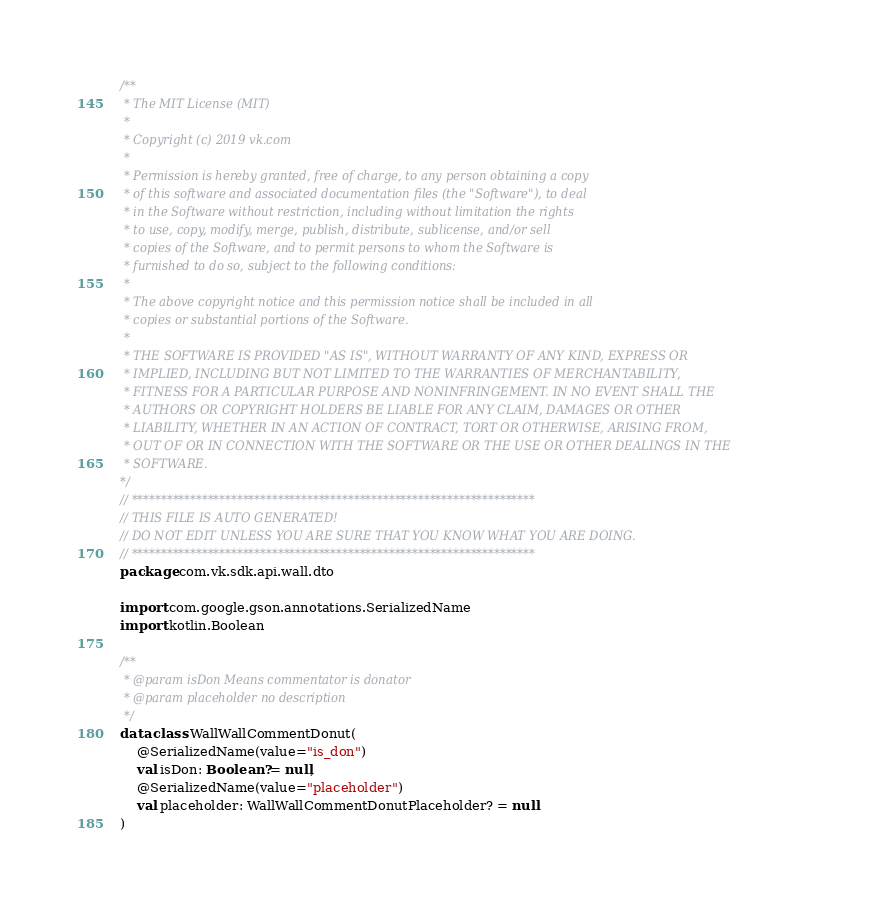Convert code to text. <code><loc_0><loc_0><loc_500><loc_500><_Kotlin_>/**
 * The MIT License (MIT)
 *
 * Copyright (c) 2019 vk.com
 *
 * Permission is hereby granted, free of charge, to any person obtaining a copy
 * of this software and associated documentation files (the "Software"), to deal
 * in the Software without restriction, including without limitation the rights
 * to use, copy, modify, merge, publish, distribute, sublicense, and/or sell
 * copies of the Software, and to permit persons to whom the Software is
 * furnished to do so, subject to the following conditions:
 *
 * The above copyright notice and this permission notice shall be included in all
 * copies or substantial portions of the Software.
 *
 * THE SOFTWARE IS PROVIDED "AS IS", WITHOUT WARRANTY OF ANY KIND, EXPRESS OR
 * IMPLIED, INCLUDING BUT NOT LIMITED TO THE WARRANTIES OF MERCHANTABILITY,
 * FITNESS FOR A PARTICULAR PURPOSE AND NONINFRINGEMENT. IN NO EVENT SHALL THE
 * AUTHORS OR COPYRIGHT HOLDERS BE LIABLE FOR ANY CLAIM, DAMAGES OR OTHER
 * LIABILITY, WHETHER IN AN ACTION OF CONTRACT, TORT OR OTHERWISE, ARISING FROM,
 * OUT OF OR IN CONNECTION WITH THE SOFTWARE OR THE USE OR OTHER DEALINGS IN THE
 * SOFTWARE.
*/
// *********************************************************************
// THIS FILE IS AUTO GENERATED!
// DO NOT EDIT UNLESS YOU ARE SURE THAT YOU KNOW WHAT YOU ARE DOING.
// *********************************************************************
package com.vk.sdk.api.wall.dto

import com.google.gson.annotations.SerializedName
import kotlin.Boolean

/**
 * @param isDon Means commentator is donator
 * @param placeholder no description
 */
data class WallWallCommentDonut(
    @SerializedName(value="is_don")
    val isDon: Boolean? = null,
    @SerializedName(value="placeholder")
    val placeholder: WallWallCommentDonutPlaceholder? = null
)
</code> 